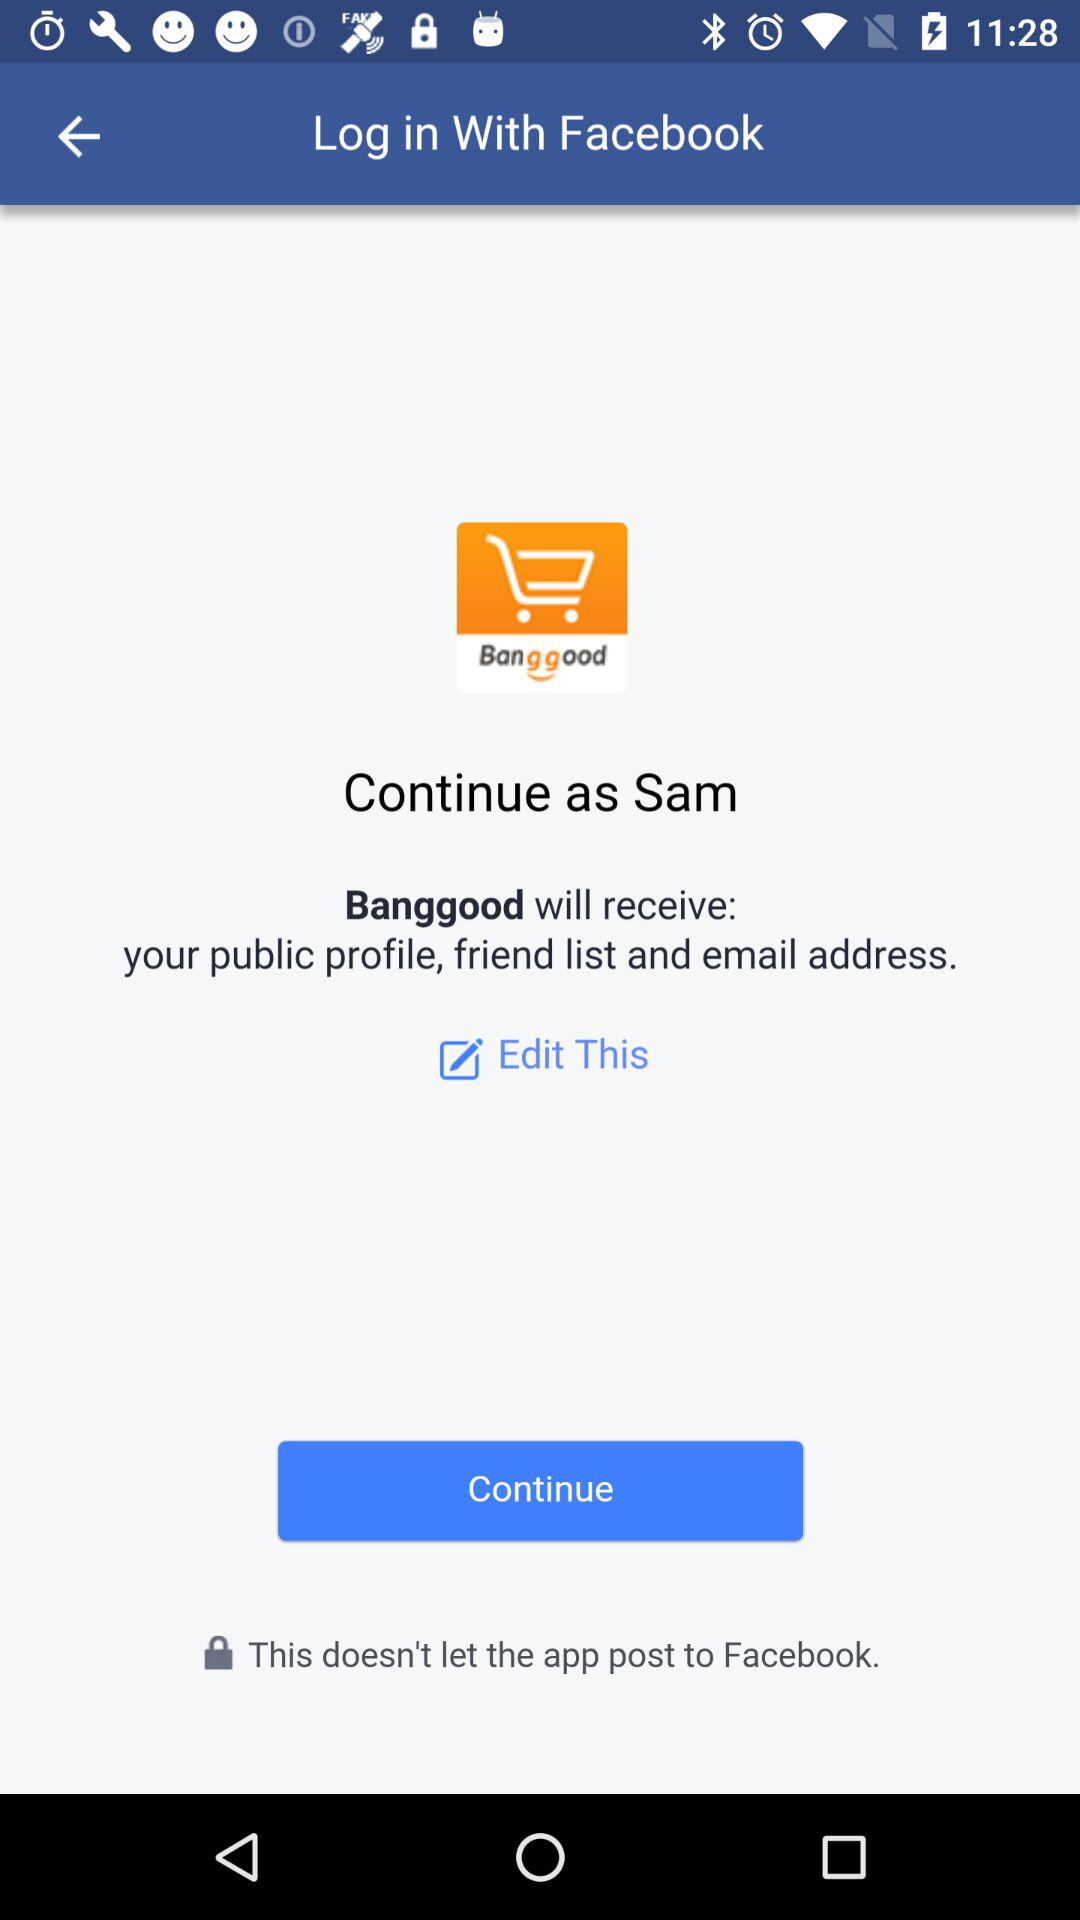What is the login name? The login name is Sam. 